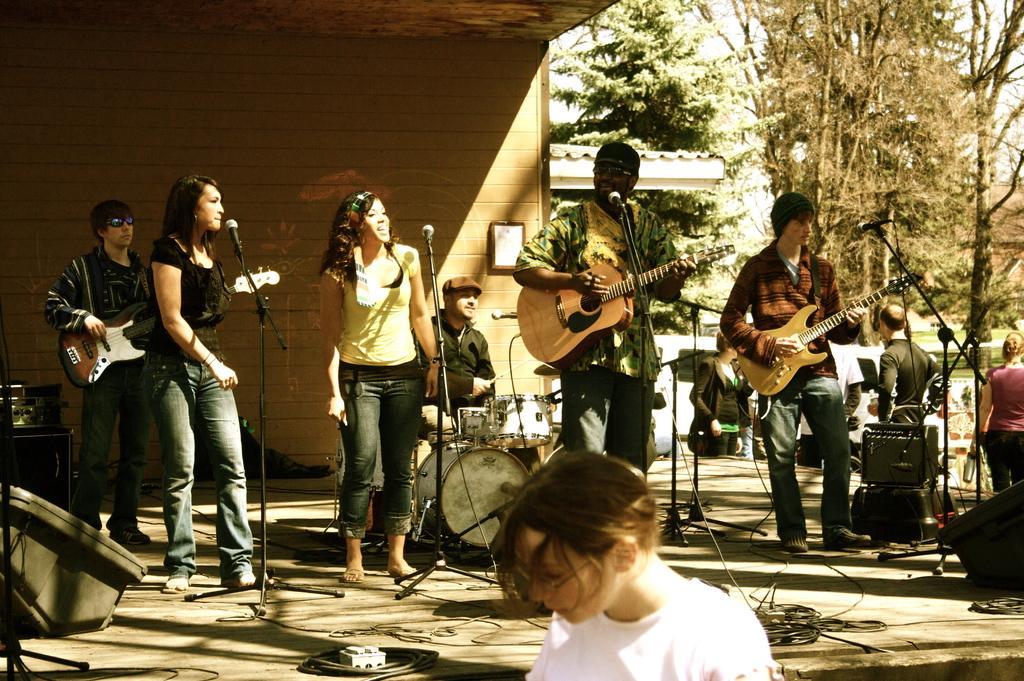Can you describe this image briefly? Group of people standing and These three persons holding guitar and this person sitting and playing instrument.. On the background we can see trees and wall. We can see microphones with stand. On the floor we can see cables. 